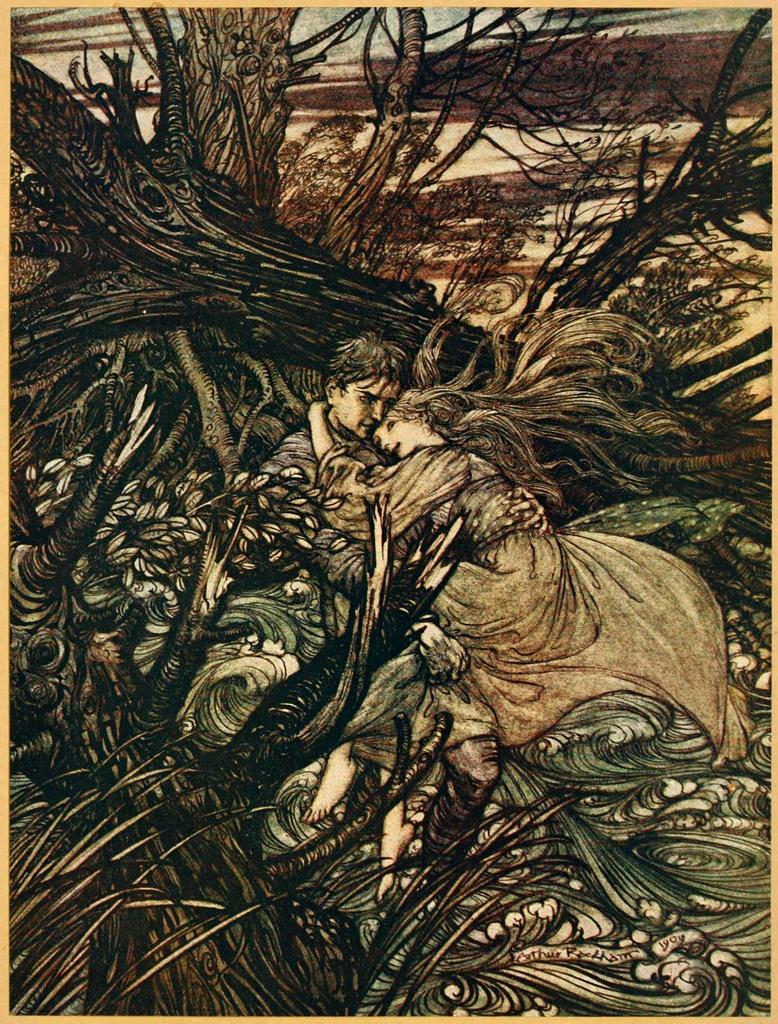What type of artwork is depicted in the image? The image is a painting. How many people are in the painting? There is a man and a woman in the painting. What are the man and woman doing in the painting? The man and woman are holding each other in the painting. What type of natural scenery is present in the painting? There are trees in the painting. Where is the store located in the painting? There is no store present in the painting; it features a man and a woman holding each other amidst trees. What type of cannon is visible in the painting? There is no cannon present in the painting. 